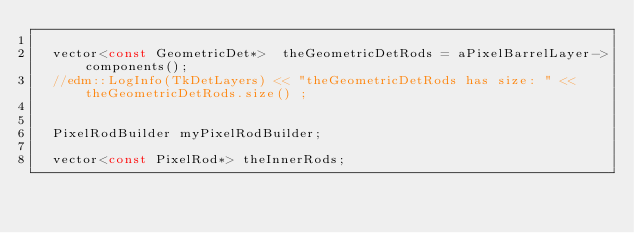Convert code to text. <code><loc_0><loc_0><loc_500><loc_500><_C++_>
  vector<const GeometricDet*>  theGeometricDetRods = aPixelBarrelLayer->components();
  //edm::LogInfo(TkDetLayers) << "theGeometricDetRods has size: " << theGeometricDetRods.size() ;  
  

  PixelRodBuilder myPixelRodBuilder;

  vector<const PixelRod*> theInnerRods;</code> 